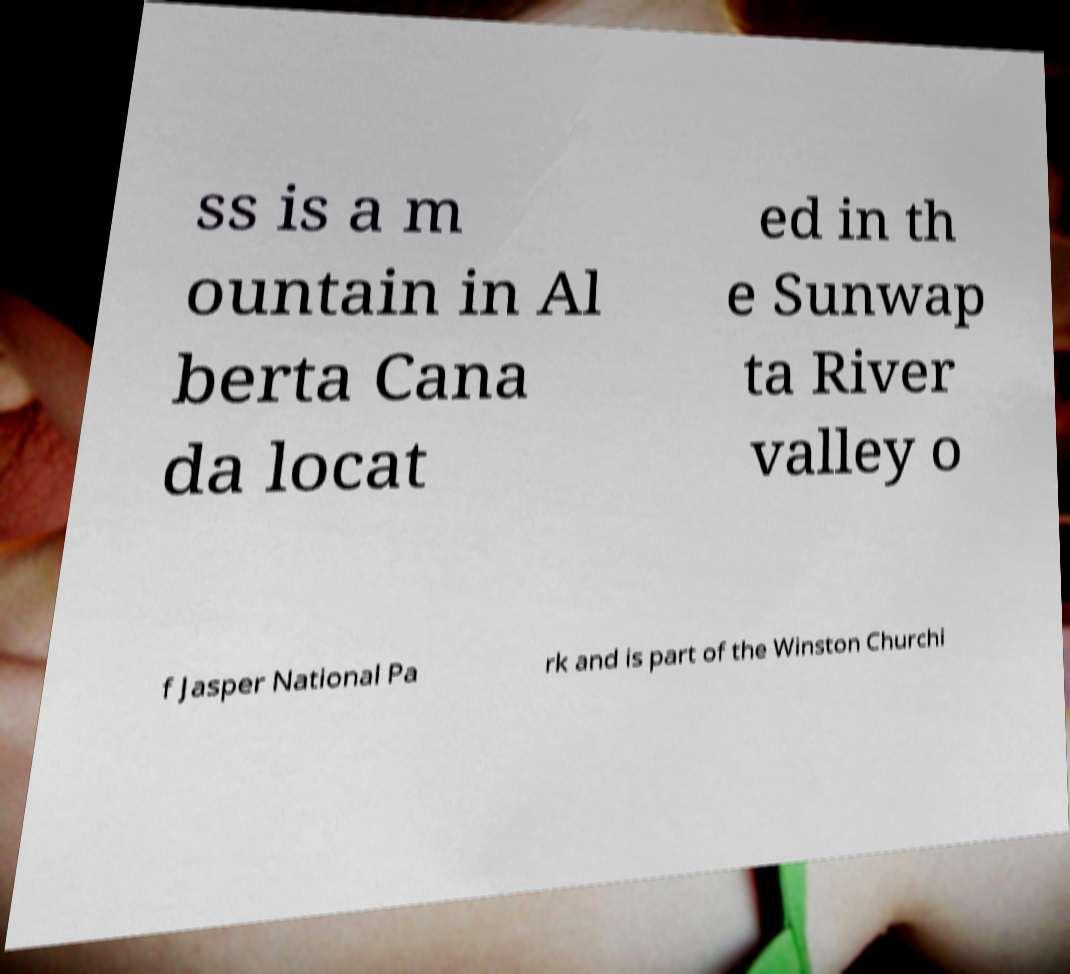For documentation purposes, I need the text within this image transcribed. Could you provide that? ss is a m ountain in Al berta Cana da locat ed in th e Sunwap ta River valley o f Jasper National Pa rk and is part of the Winston Churchi 